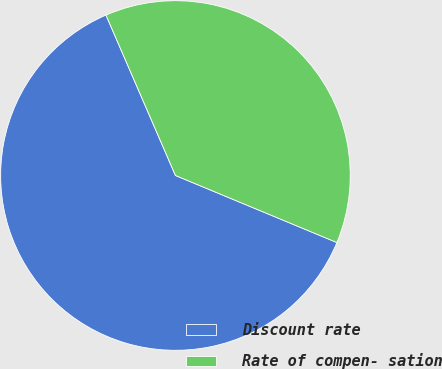<chart> <loc_0><loc_0><loc_500><loc_500><pie_chart><fcel>Discount rate<fcel>Rate of compen- sation<nl><fcel>62.23%<fcel>37.77%<nl></chart> 